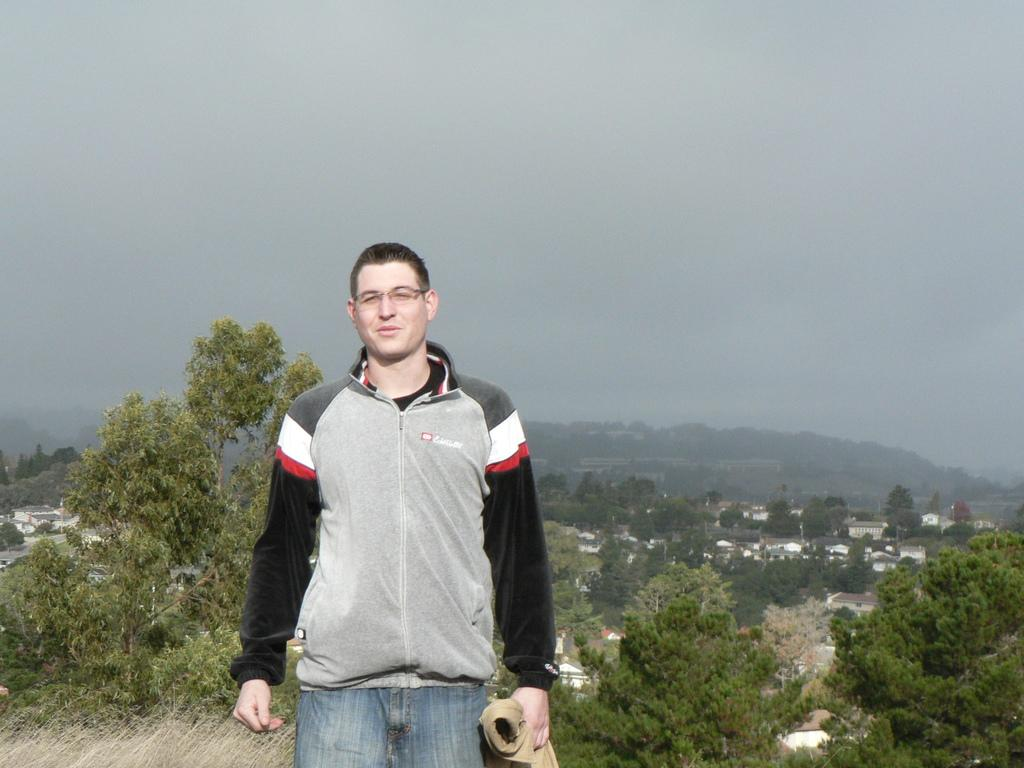What is the person in the image holding? There is a person holding an object in the image. What can be seen in the distance behind the person? There are houses, trees, and other objects in the background of the image. What is visible at the top of the image? The sky is visible at the top of the image. Can you see a snail crawling on the person's foot in the image? There is no snail or foot visible in the image. What type of collar is the person wearing in the image? There is no collar visible in the image, as the person is not wearing any clothing that would have a collar. 